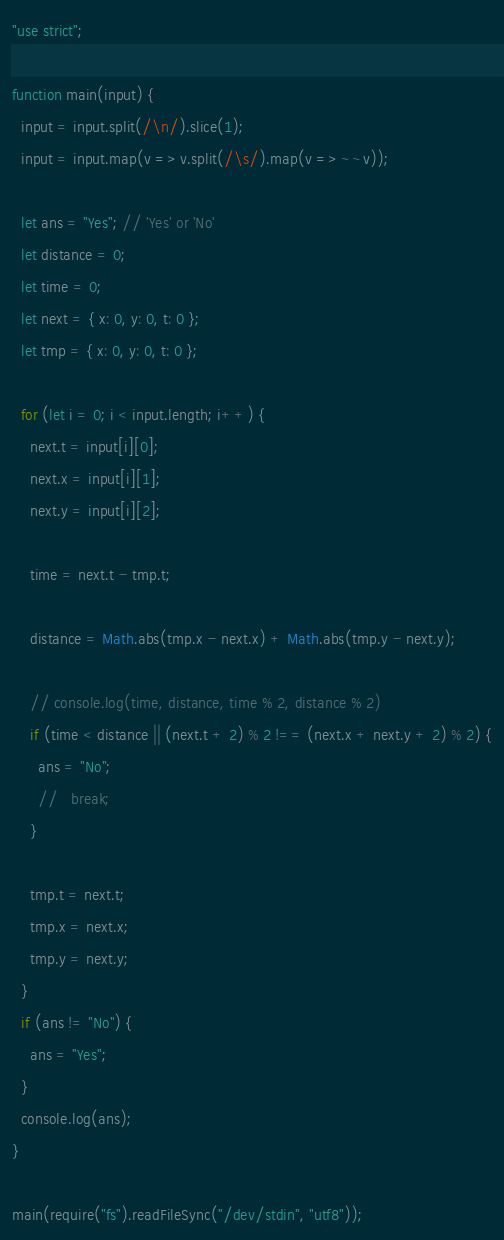<code> <loc_0><loc_0><loc_500><loc_500><_JavaScript_>"use strict";

function main(input) {
  input = input.split(/\n/).slice(1);
  input = input.map(v => v.split(/\s/).map(v => ~~v));

  let ans = "Yes"; // 'Yes' or 'No'
  let distance = 0;
  let time = 0;
  let next = { x: 0, y: 0, t: 0 };
  let tmp = { x: 0, y: 0, t: 0 };

  for (let i = 0; i < input.length; i++) {
    next.t = input[i][0];
    next.x = input[i][1];
    next.y = input[i][2];

    time = next.t - tmp.t;

    distance = Math.abs(tmp.x - next.x) + Math.abs(tmp.y - next.y);

    // console.log(time, distance, time % 2, distance % 2)
    if (time < distance || (next.t + 2) % 2 !== (next.x + next.y + 2) % 2) {
      ans = "No";
      //   break;
    }

    tmp.t = next.t;
    tmp.x = next.x;
    tmp.y = next.y;
  }
  if (ans != "No") {
    ans = "Yes";
  }
  console.log(ans);
}

main(require("fs").readFileSync("/dev/stdin", "utf8"));
</code> 